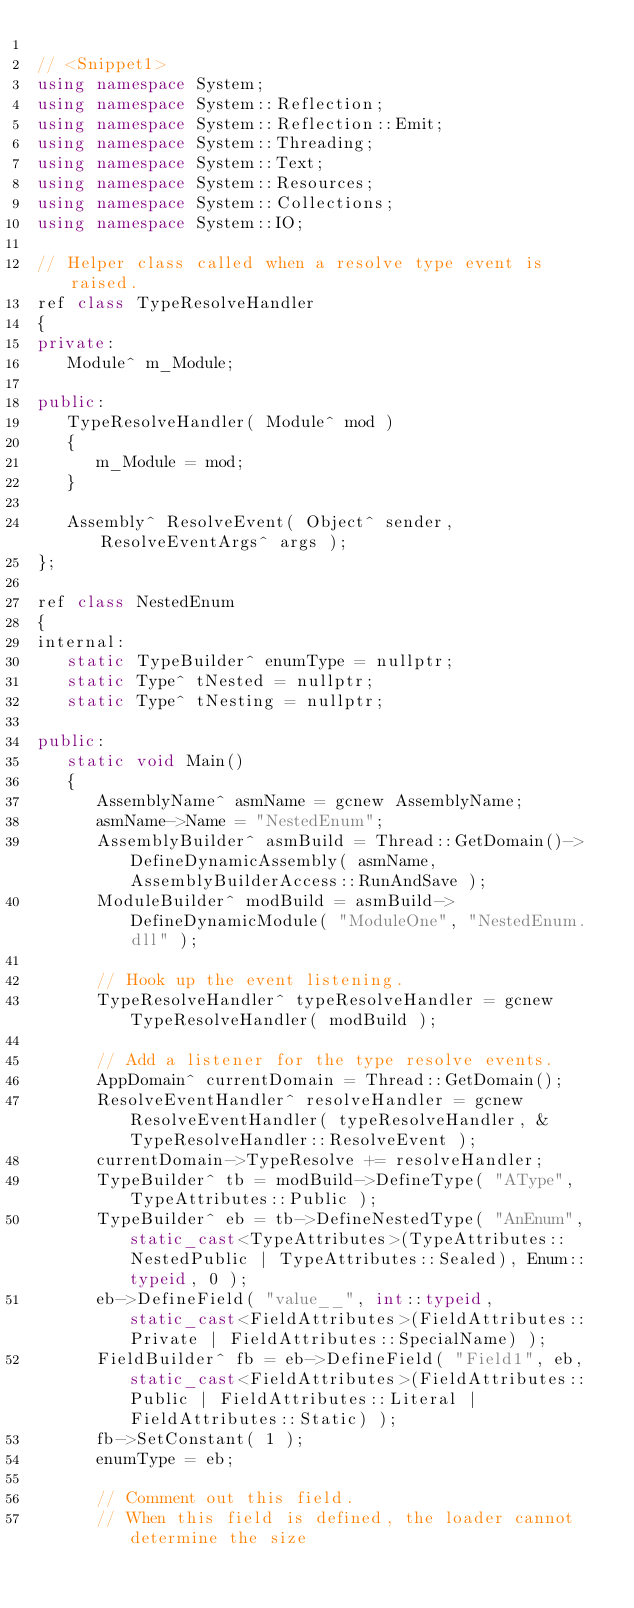Convert code to text. <code><loc_0><loc_0><loc_500><loc_500><_C++_>
// <Snippet1>
using namespace System;
using namespace System::Reflection;
using namespace System::Reflection::Emit;
using namespace System::Threading;
using namespace System::Text;
using namespace System::Resources;
using namespace System::Collections;
using namespace System::IO;

// Helper class called when a resolve type event is raised.
ref class TypeResolveHandler
{
private:
   Module^ m_Module;

public:
   TypeResolveHandler( Module^ mod )
   {
      m_Module = mod;
   }

   Assembly^ ResolveEvent( Object^ sender, ResolveEventArgs^ args );
};

ref class NestedEnum
{
internal:
   static TypeBuilder^ enumType = nullptr;
   static Type^ tNested = nullptr;
   static Type^ tNesting = nullptr;

public:
   static void Main()
   {
      AssemblyName^ asmName = gcnew AssemblyName;
      asmName->Name = "NestedEnum";
      AssemblyBuilder^ asmBuild = Thread::GetDomain()->DefineDynamicAssembly( asmName, AssemblyBuilderAccess::RunAndSave );
      ModuleBuilder^ modBuild = asmBuild->DefineDynamicModule( "ModuleOne", "NestedEnum.dll" );
      
      // Hook up the event listening.
      TypeResolveHandler^ typeResolveHandler = gcnew TypeResolveHandler( modBuild );
      
      // Add a listener for the type resolve events.
      AppDomain^ currentDomain = Thread::GetDomain();
      ResolveEventHandler^ resolveHandler = gcnew ResolveEventHandler( typeResolveHandler, &TypeResolveHandler::ResolveEvent );
      currentDomain->TypeResolve += resolveHandler;
      TypeBuilder^ tb = modBuild->DefineType( "AType", TypeAttributes::Public );
      TypeBuilder^ eb = tb->DefineNestedType( "AnEnum", static_cast<TypeAttributes>(TypeAttributes::NestedPublic | TypeAttributes::Sealed), Enum::typeid, 0 );
      eb->DefineField( "value__", int::typeid, static_cast<FieldAttributes>(FieldAttributes::Private | FieldAttributes::SpecialName) );
      FieldBuilder^ fb = eb->DefineField( "Field1", eb, static_cast<FieldAttributes>(FieldAttributes::Public | FieldAttributes::Literal | FieldAttributes::Static) );
      fb->SetConstant( 1 );
      enumType = eb;
      
      // Comment out this field.
      // When this field is defined, the loader cannot determine the size</code> 